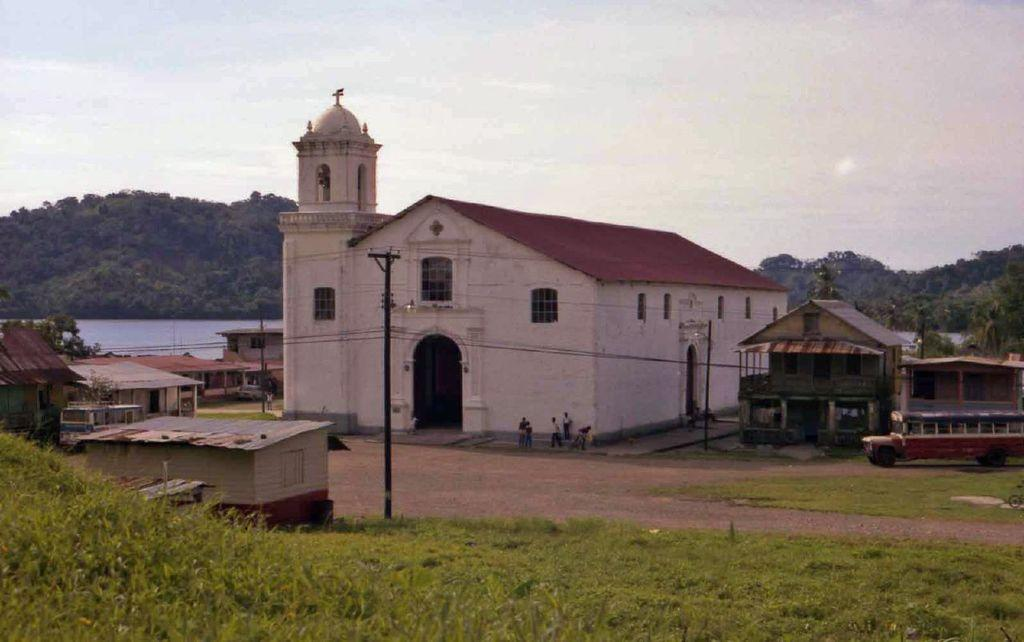What is the main subject in the center of the image? There are houses in the center of the image. What type of terrain is visible at the bottom side of the image? There is grassland at the bottom side of the image. What can be seen in the background area of the image? There are trees in the background area of the image. Where are the books and dolls located in the image? There are no books or dolls present in the image. Is there a band playing in the background of the image? There is no band present in the image. 